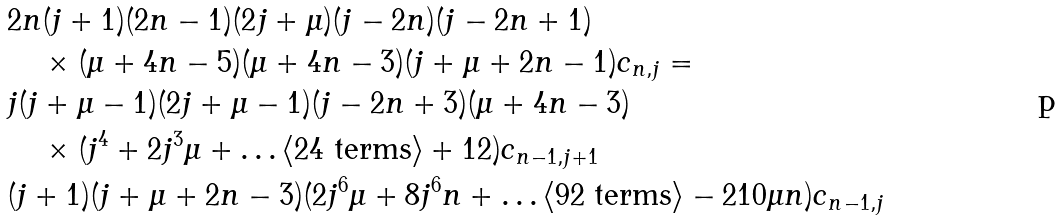<formula> <loc_0><loc_0><loc_500><loc_500>& 2 n ( j + 1 ) ( 2 n - 1 ) ( 2 j + \mu ) ( j - 2 n ) ( j - 2 n + 1 ) \\ & \quad \times ( \mu + 4 n - 5 ) ( \mu + 4 n - 3 ) ( j + \mu + 2 n - 1 ) c _ { n , j } = \\ & j ( j + \mu - 1 ) ( 2 j + \mu - 1 ) ( j - 2 n + 3 ) ( \mu + 4 n - 3 ) \\ & \quad \times ( j ^ { 4 } + 2 j ^ { 3 } \mu + \dots \langle 2 4 \ \text {terms} \rangle + 1 2 ) c _ { n - 1 , j + 1 } \\ & ( j + 1 ) ( j + \mu + 2 n - 3 ) ( 2 j ^ { 6 } \mu + 8 j ^ { 6 } n + \dots \langle 9 2 \ \text {terms} \rangle - 2 1 0 \mu n ) c _ { n - 1 , j }</formula> 